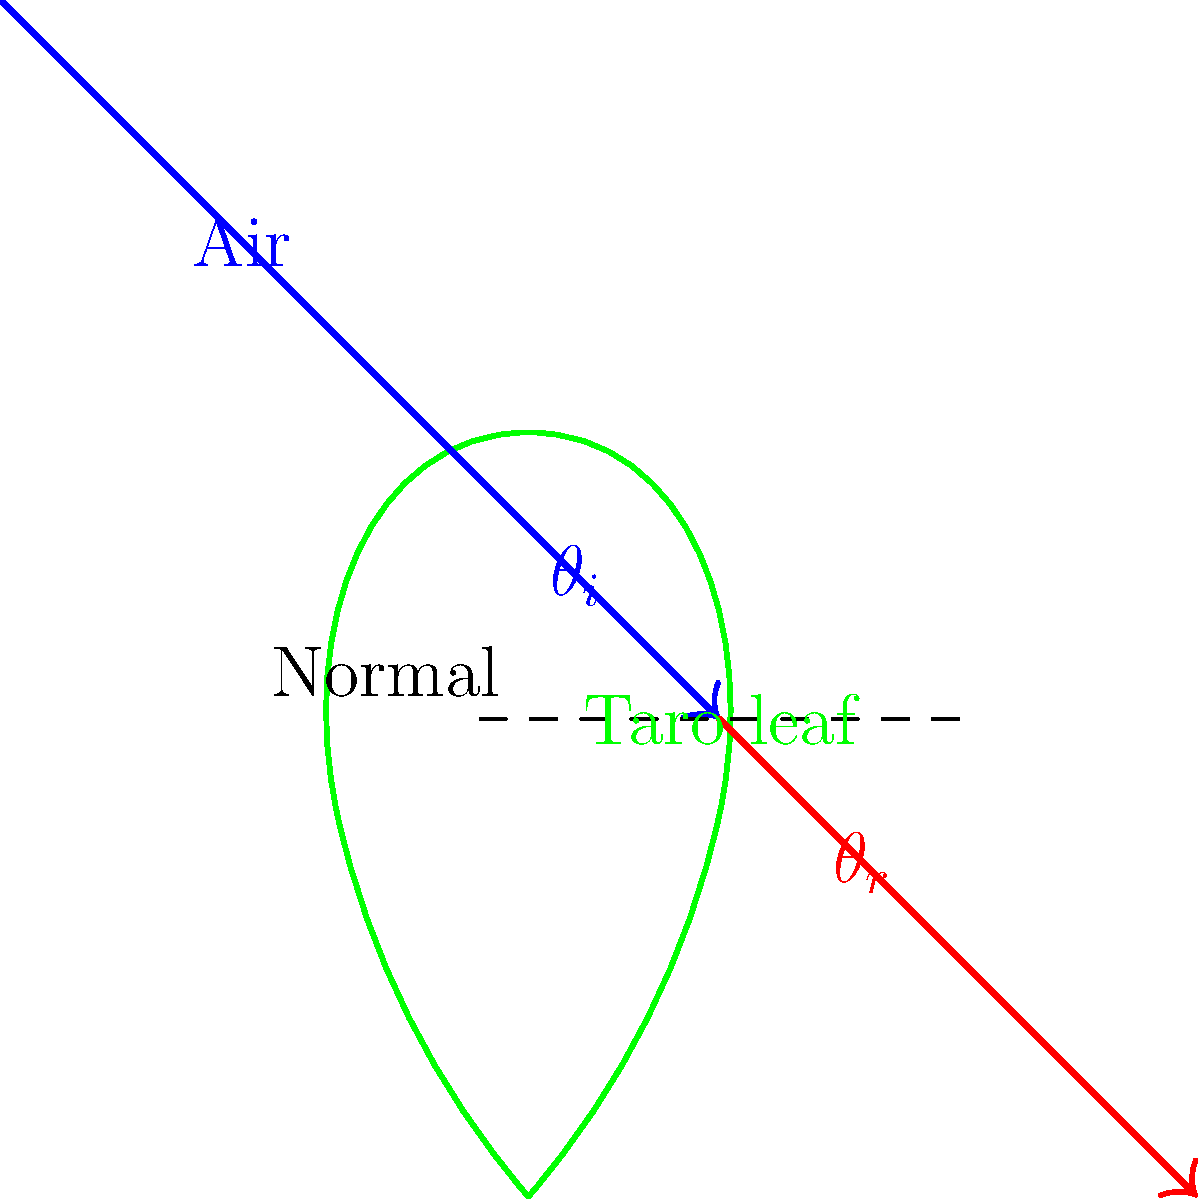In the context of studying the refraction of light through a taro leaf, a plant significant in ancient Hawaiian culture, how does Snell's law apply to the diagram? Express your answer in terms of the refractive indices of air ($n_1$) and the taro leaf ($n_2$), and the angles of incidence ($\theta_i$) and refraction ($\theta_r$). To understand how Snell's law applies to the refraction of light through a taro leaf, let's follow these steps:

1. Identify the media: 
   - Medium 1 is air (refractive index $n_1$)
   - Medium 2 is the taro leaf (refractive index $n_2$)

2. Identify the angles:
   - $\theta_i$ is the angle of incidence (in air)
   - $\theta_r$ is the angle of refraction (in the taro leaf)

3. Recall Snell's law:
   Snell's law states that the ratio of the sines of the angles of incidence and refraction is equivalent to the ratio of phase velocities in the two media, or equivalent to the opposite ratio of the indices of refraction:

   $$n_1 \sin(\theta_i) = n_2 \sin(\theta_r)$$

4. Apply Snell's law to this specific scenario:
   As light passes from air into the taro leaf, it bends towards the normal because the leaf is denser than air ($n_2 > n_1$). This is represented in the diagram by the change in direction of the light ray.

5. Interpret the result:
   The equation shows that the sine of the angle of incidence in air multiplied by the refractive index of air equals the sine of the angle of refraction in the taro leaf multiplied by the refractive index of the taro leaf.

This law explains why the light bends as it enters the taro leaf, a phenomenon that would have been observed by ancient Hawaiians in their natural environment, potentially influencing their understanding of light and vision.
Answer: $n_1 \sin(\theta_i) = n_2 \sin(\theta_r)$ 